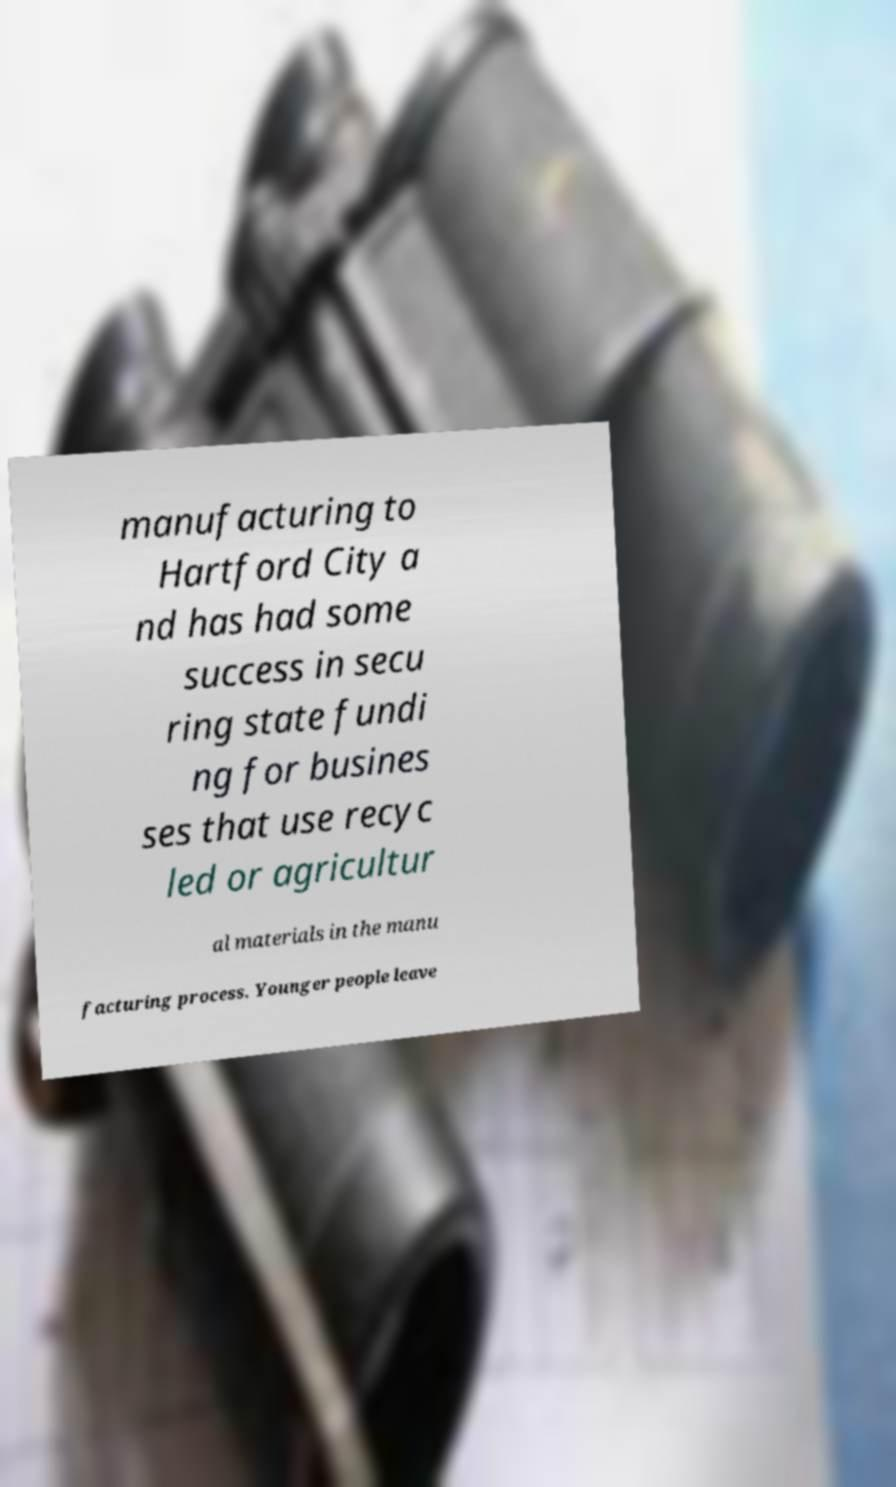Can you accurately transcribe the text from the provided image for me? manufacturing to Hartford City a nd has had some success in secu ring state fundi ng for busines ses that use recyc led or agricultur al materials in the manu facturing process. Younger people leave 